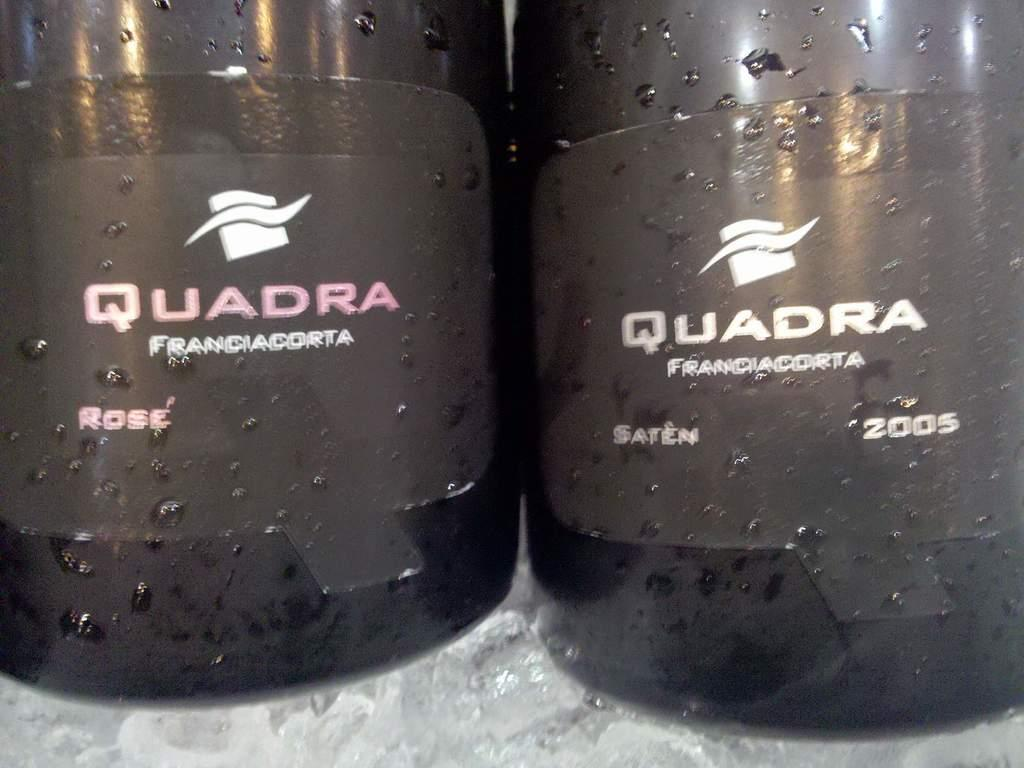<image>
Present a compact description of the photo's key features. Two bottles of quadra branded drink with one being rose and the other saten. 